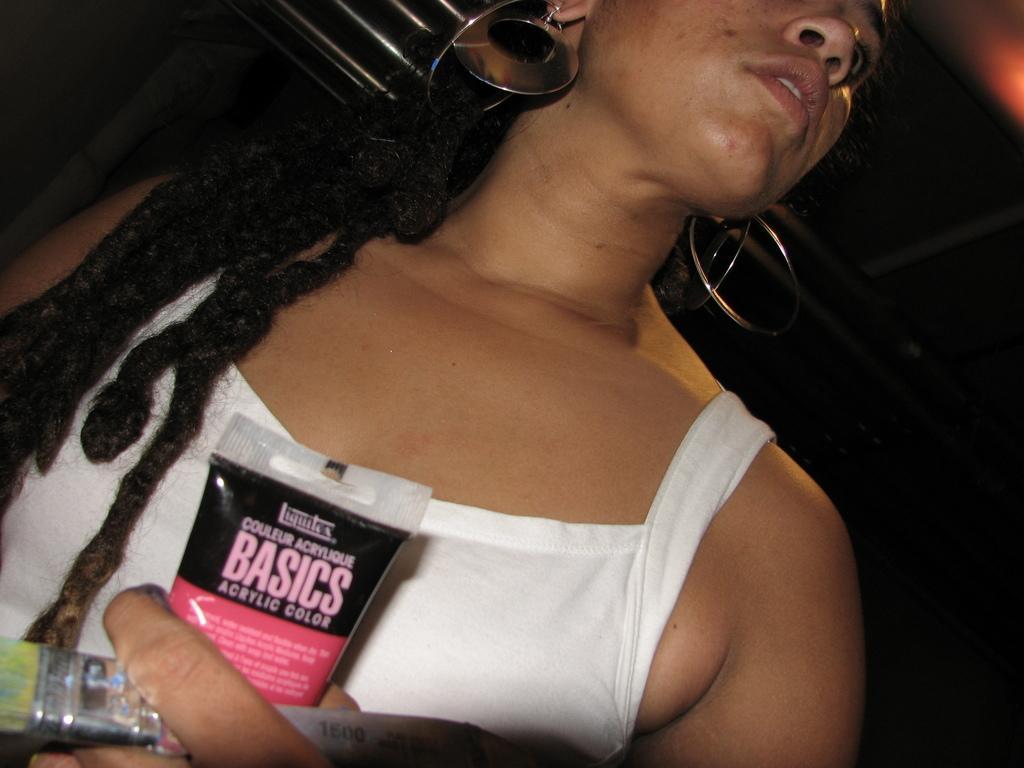Can you describe this image briefly? In this picture we can see a woman holding a tube and a brush in her hand. There is an orange light in the top right. 